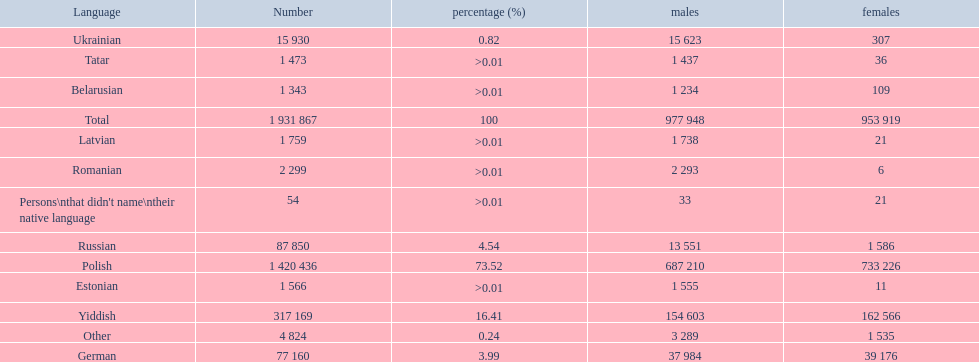I'm looking to parse the entire table for insights. Could you assist me with that? {'header': ['Language', 'Number', 'percentage (%)', 'males', 'females'], 'rows': [['Ukrainian', '15 930', '0.82', '15 623', '307'], ['Tatar', '1 473', '>0.01', '1 437', '36'], ['Belarusian', '1 343', '>0.01', '1 234', '109'], ['Total', '1 931 867', '100', '977 948', '953 919'], ['Latvian', '1 759', '>0.01', '1 738', '21'], ['Romanian', '2 299', '>0.01', '2 293', '6'], ["Persons\\nthat didn't name\\ntheir native language", '54', '>0.01', '33', '21'], ['Russian', '87 850', '4.54', '13 551', '1 586'], ['Polish', '1 420 436', '73.52', '687 210', '733 226'], ['Estonian', '1 566', '>0.01', '1 555', '11'], ['Yiddish', '317 169', '16.41', '154 603', '162 566'], ['Other', '4 824', '0.24', '3 289', '1 535'], ['German', '77 160', '3.99', '37 984', '39 176']]} Number of male russian speakers 13 551. 